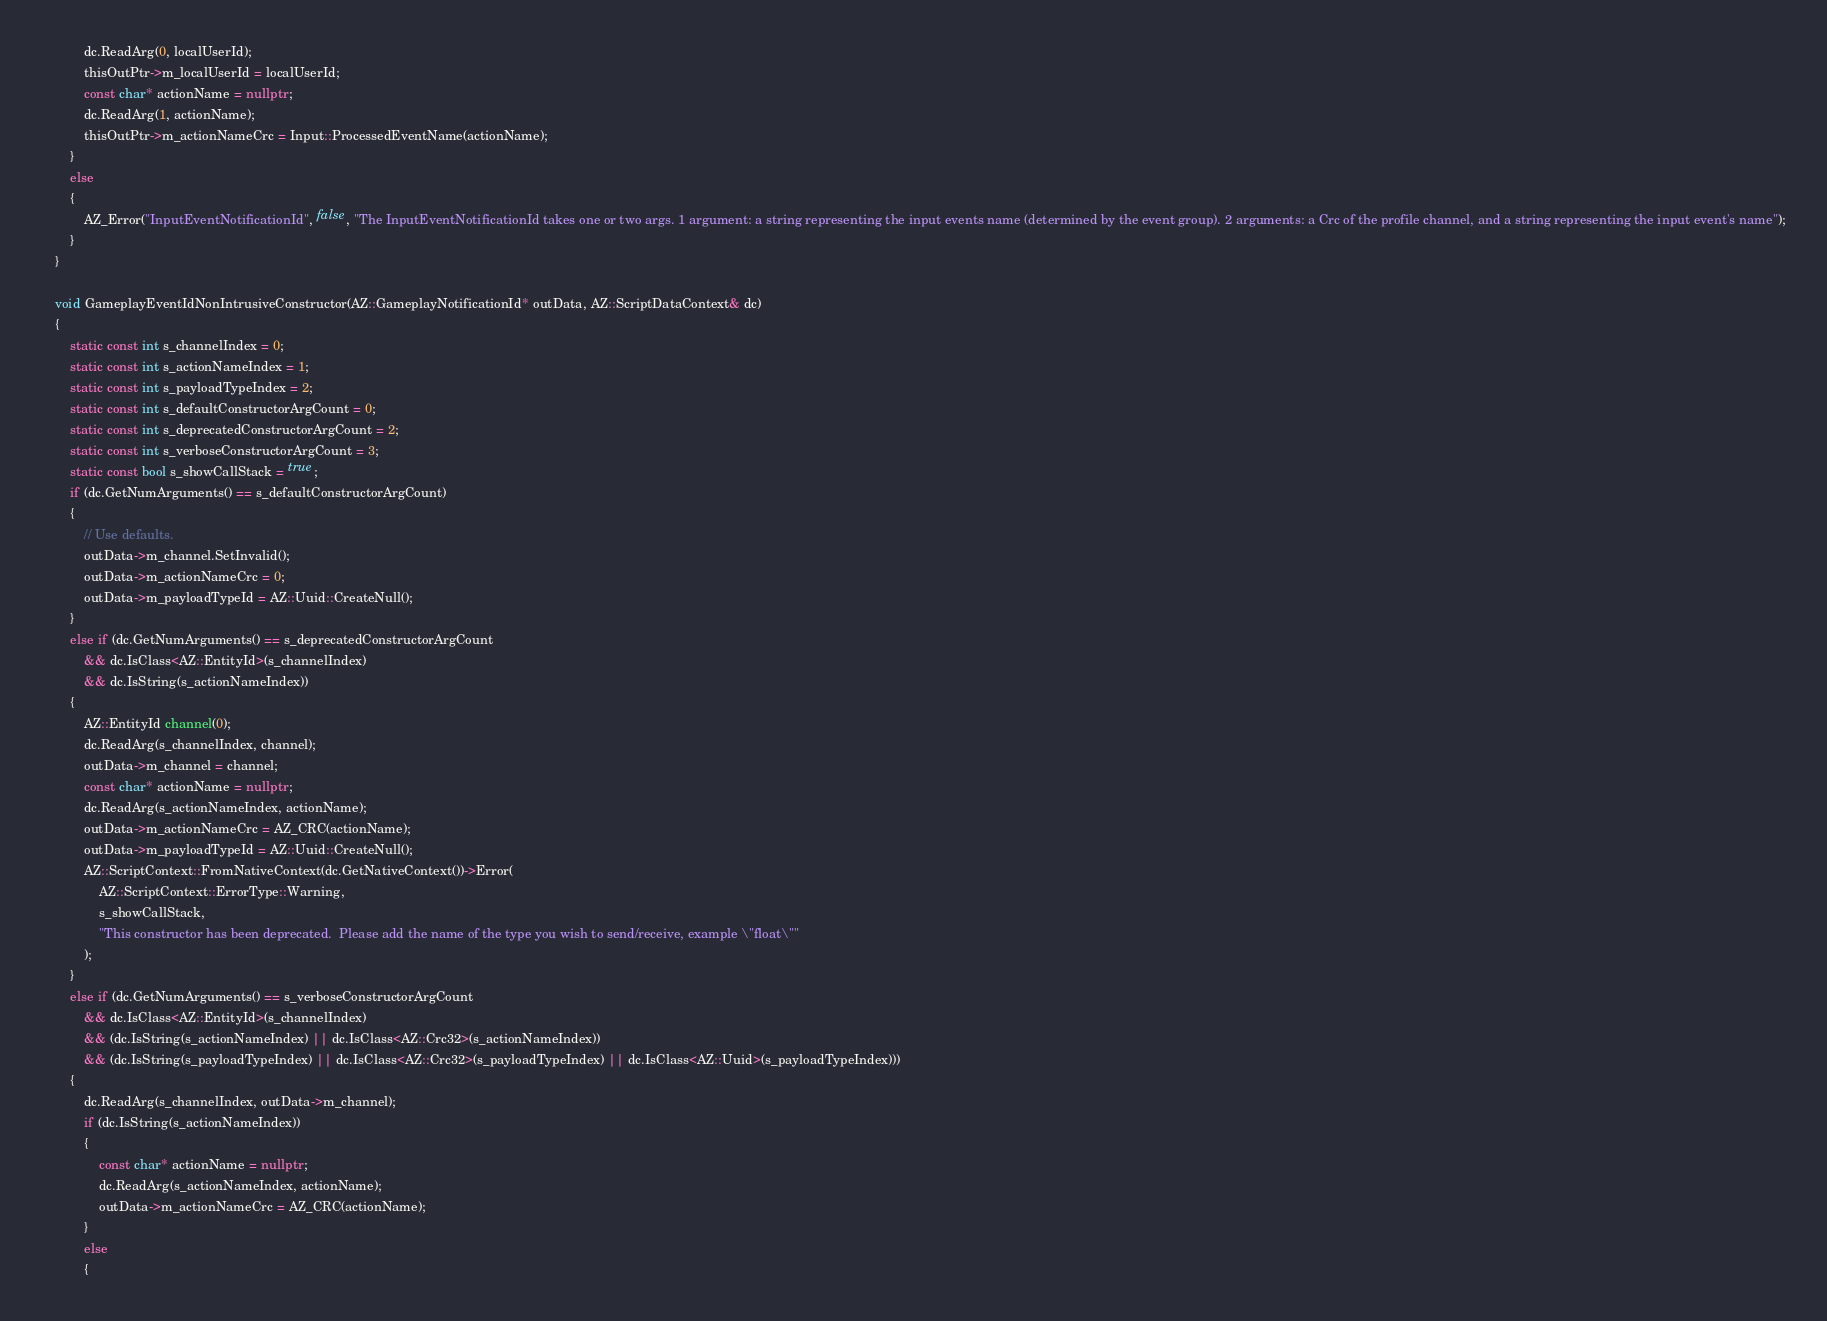<code> <loc_0><loc_0><loc_500><loc_500><_C++_>            dc.ReadArg(0, localUserId);
            thisOutPtr->m_localUserId = localUserId;
            const char* actionName = nullptr;
            dc.ReadArg(1, actionName);
            thisOutPtr->m_actionNameCrc = Input::ProcessedEventName(actionName);
        }
        else
        {
            AZ_Error("InputEventNotificationId", false, "The InputEventNotificationId takes one or two args. 1 argument: a string representing the input events name (determined by the event group). 2 arguments: a Crc of the profile channel, and a string representing the input event's name");
        }
    }

    void GameplayEventIdNonIntrusiveConstructor(AZ::GameplayNotificationId* outData, AZ::ScriptDataContext& dc)
    {
        static const int s_channelIndex = 0;
        static const int s_actionNameIndex = 1;
        static const int s_payloadTypeIndex = 2;
        static const int s_defaultConstructorArgCount = 0;
        static const int s_deprecatedConstructorArgCount = 2;
        static const int s_verboseConstructorArgCount = 3;
        static const bool s_showCallStack = true;
        if (dc.GetNumArguments() == s_defaultConstructorArgCount)
        {
            // Use defaults.
            outData->m_channel.SetInvalid();
            outData->m_actionNameCrc = 0;
            outData->m_payloadTypeId = AZ::Uuid::CreateNull();
        }
        else if (dc.GetNumArguments() == s_deprecatedConstructorArgCount 
            && dc.IsClass<AZ::EntityId>(s_channelIndex) 
            && dc.IsString(s_actionNameIndex))
        {
            AZ::EntityId channel(0);
            dc.ReadArg(s_channelIndex, channel);
            outData->m_channel = channel;
            const char* actionName = nullptr;
            dc.ReadArg(s_actionNameIndex, actionName);
            outData->m_actionNameCrc = AZ_CRC(actionName);
            outData->m_payloadTypeId = AZ::Uuid::CreateNull();
            AZ::ScriptContext::FromNativeContext(dc.GetNativeContext())->Error(
                AZ::ScriptContext::ErrorType::Warning, 
                s_showCallStack,
                "This constructor has been deprecated.  Please add the name of the type you wish to send/receive, example \"float\""
            );
        }
        else if (dc.GetNumArguments() == s_verboseConstructorArgCount 
            && dc.IsClass<AZ::EntityId>(s_channelIndex)
            && (dc.IsString(s_actionNameIndex) || dc.IsClass<AZ::Crc32>(s_actionNameIndex))
            && (dc.IsString(s_payloadTypeIndex) || dc.IsClass<AZ::Crc32>(s_payloadTypeIndex) || dc.IsClass<AZ::Uuid>(s_payloadTypeIndex)))
        {
            dc.ReadArg(s_channelIndex, outData->m_channel);
            if (dc.IsString(s_actionNameIndex))
            {
                const char* actionName = nullptr;
                dc.ReadArg(s_actionNameIndex, actionName);
                outData->m_actionNameCrc = AZ_CRC(actionName);
            }
            else
            {</code> 